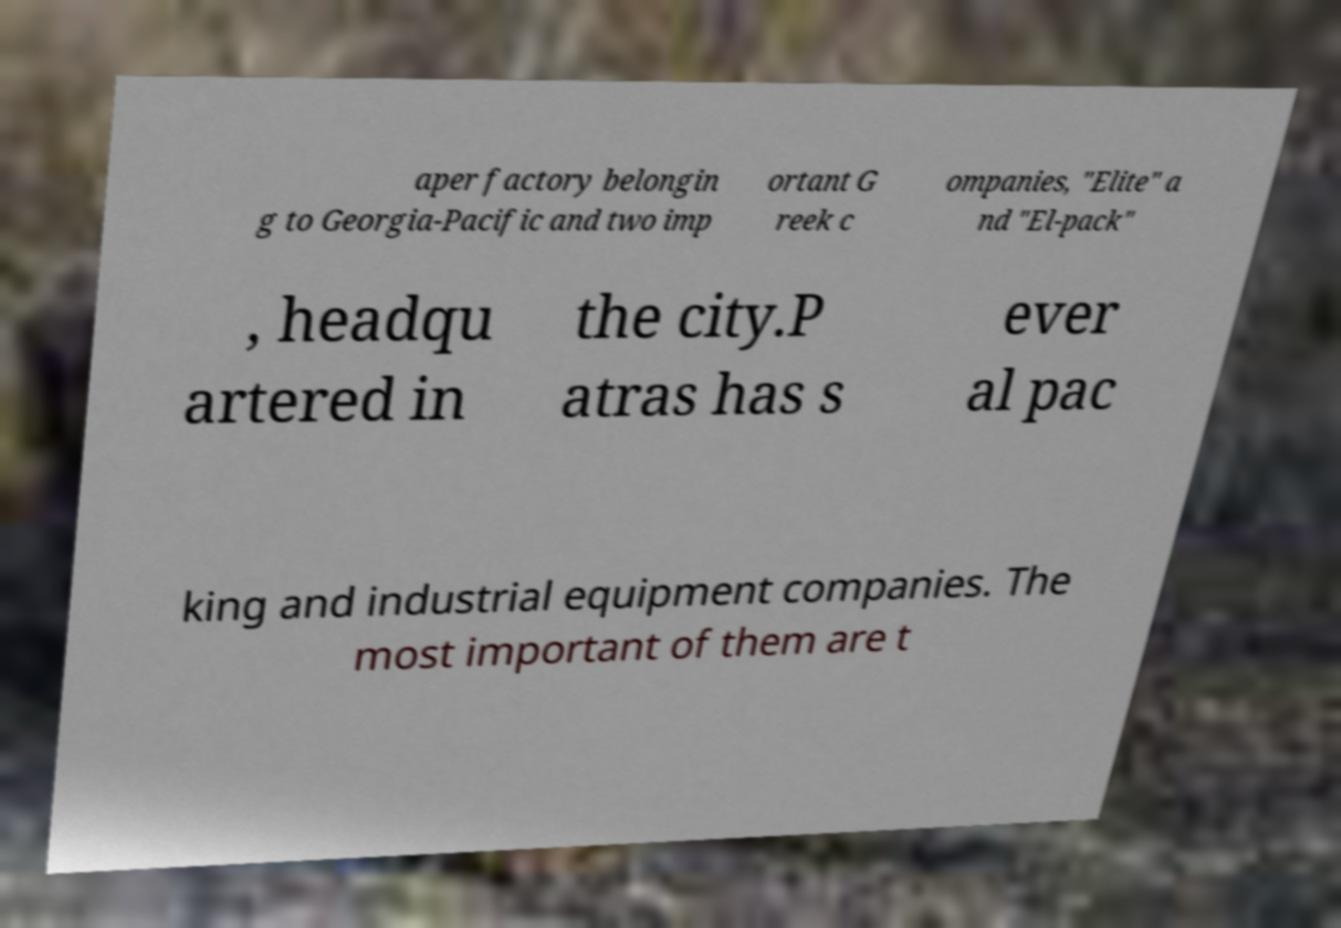Please identify and transcribe the text found in this image. aper factory belongin g to Georgia-Pacific and two imp ortant G reek c ompanies, "Elite" a nd "El-pack" , headqu artered in the city.P atras has s ever al pac king and industrial equipment companies. The most important of them are t 